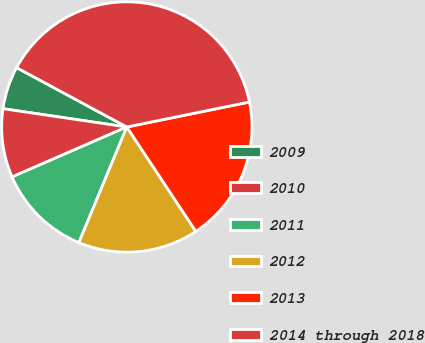Convert chart to OTSL. <chart><loc_0><loc_0><loc_500><loc_500><pie_chart><fcel>2009<fcel>2010<fcel>2011<fcel>2012<fcel>2013<fcel>2014 through 2018<nl><fcel>5.53%<fcel>8.87%<fcel>12.21%<fcel>15.55%<fcel>18.89%<fcel>38.93%<nl></chart> 